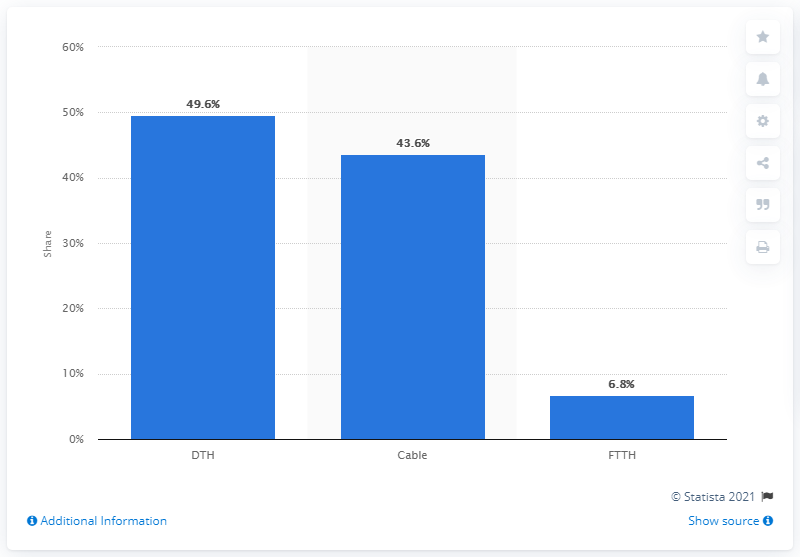Draw attention to some important aspects in this diagram. In June 2020, the most popular pay TV technology in Brazil was Direct-to-Home (DTH). In June 2020, cable was the second most popular pay TV technology in Brazil. 